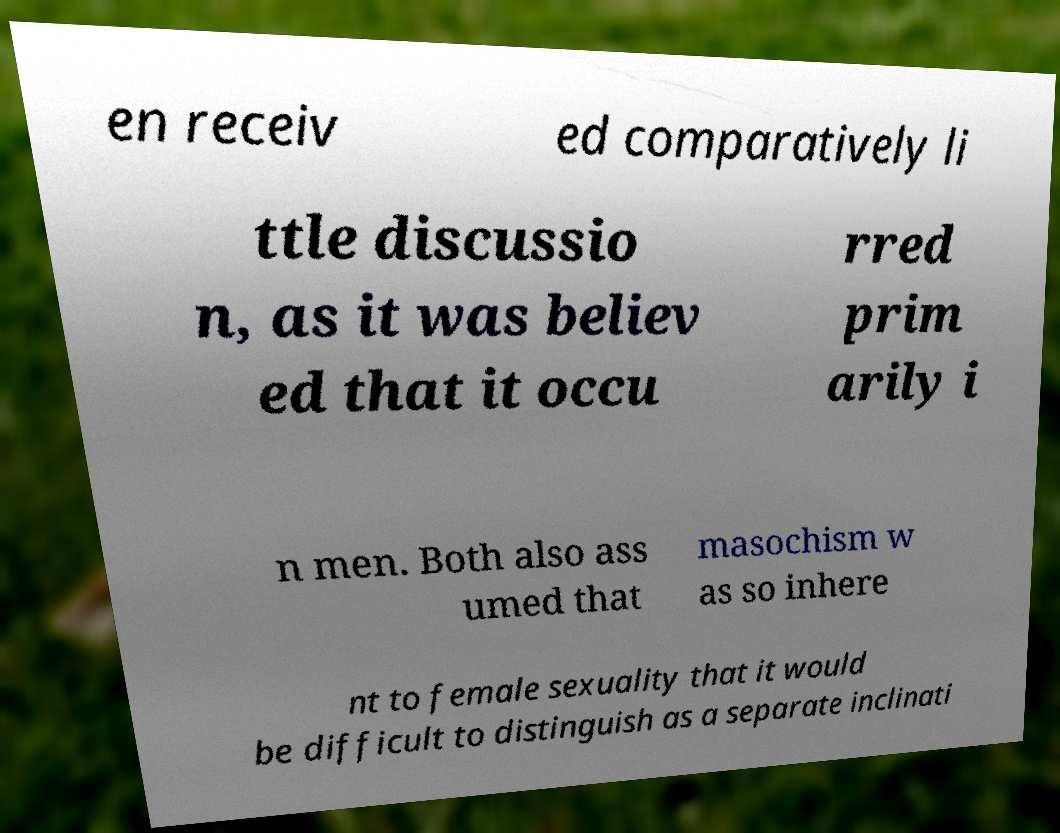What messages or text are displayed in this image? I need them in a readable, typed format. en receiv ed comparatively li ttle discussio n, as it was believ ed that it occu rred prim arily i n men. Both also ass umed that masochism w as so inhere nt to female sexuality that it would be difficult to distinguish as a separate inclinati 